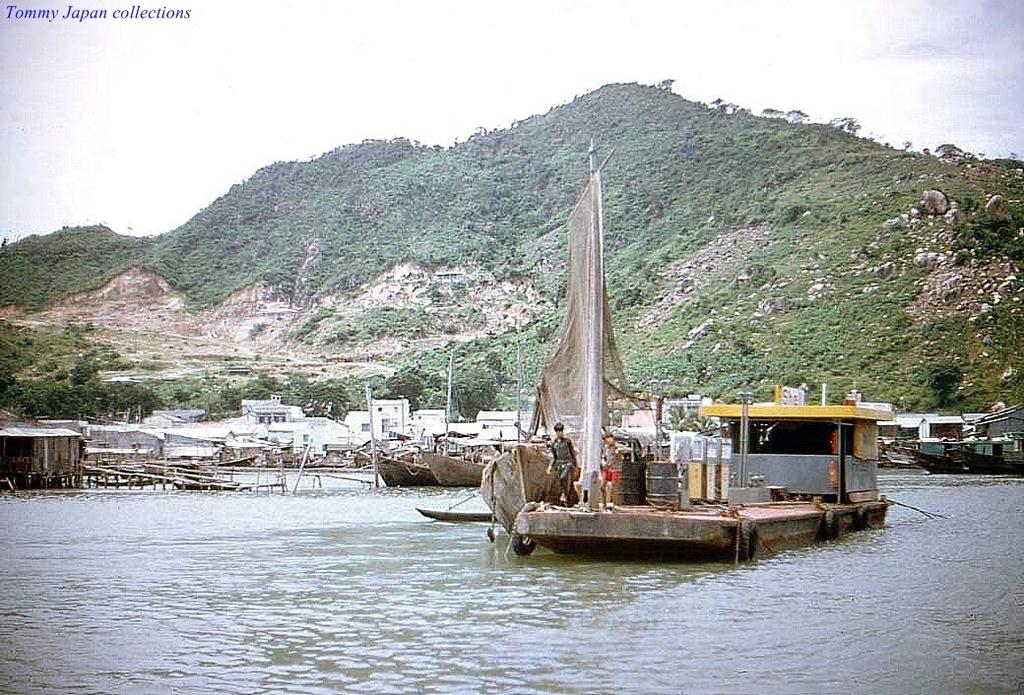What is located on the left side of the image? There is a boat on the left side of the image. What is at the bottom of the image? There is water at the bottom of the image. What can be seen in the background of the image? There are houses and trees in the background of the image. What type of line is being pulled by the boat in the image? There is no line being pulled by the boat in the image; it is simply floating on the water. 